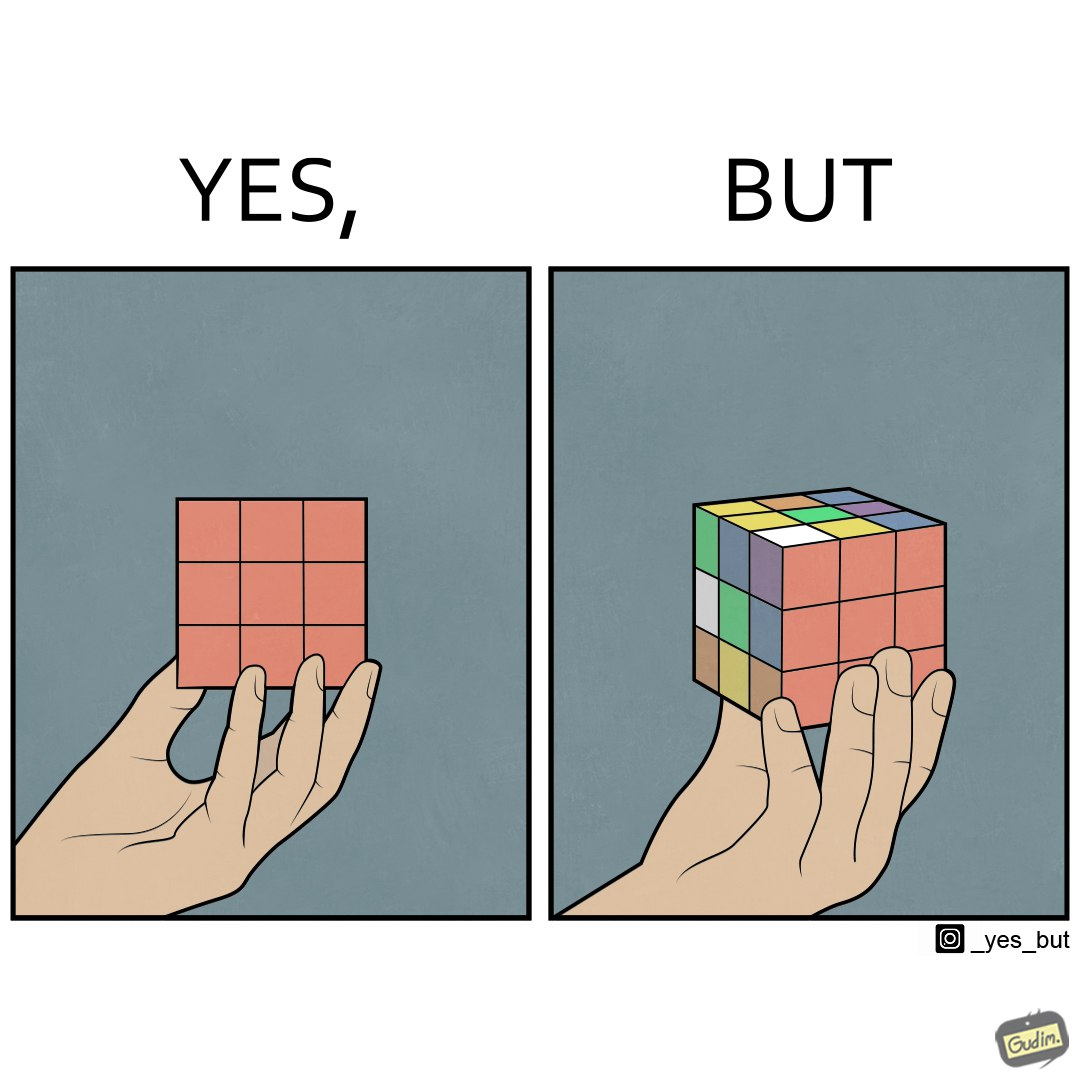Is this a satirical image? Yes, this image is satirical. 